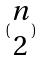<formula> <loc_0><loc_0><loc_500><loc_500>( \begin{matrix} n \\ 2 \end{matrix} )</formula> 